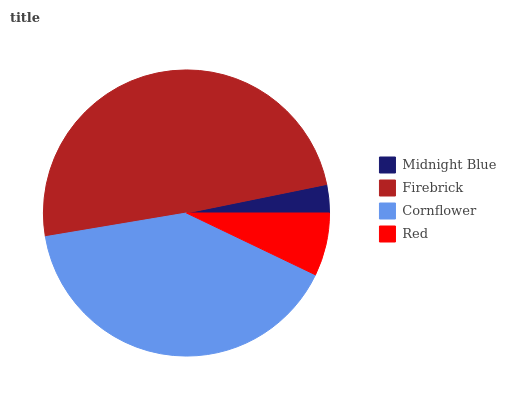Is Midnight Blue the minimum?
Answer yes or no. Yes. Is Firebrick the maximum?
Answer yes or no. Yes. Is Cornflower the minimum?
Answer yes or no. No. Is Cornflower the maximum?
Answer yes or no. No. Is Firebrick greater than Cornflower?
Answer yes or no. Yes. Is Cornflower less than Firebrick?
Answer yes or no. Yes. Is Cornflower greater than Firebrick?
Answer yes or no. No. Is Firebrick less than Cornflower?
Answer yes or no. No. Is Cornflower the high median?
Answer yes or no. Yes. Is Red the low median?
Answer yes or no. Yes. Is Firebrick the high median?
Answer yes or no. No. Is Midnight Blue the low median?
Answer yes or no. No. 